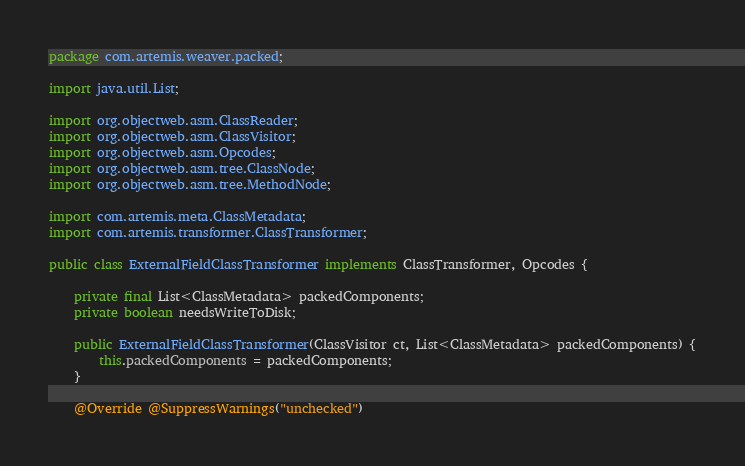Convert code to text. <code><loc_0><loc_0><loc_500><loc_500><_Java_>package com.artemis.weaver.packed;

import java.util.List;

import org.objectweb.asm.ClassReader;
import org.objectweb.asm.ClassVisitor;
import org.objectweb.asm.Opcodes;
import org.objectweb.asm.tree.ClassNode;
import org.objectweb.asm.tree.MethodNode;

import com.artemis.meta.ClassMetadata;
import com.artemis.transformer.ClassTransformer;

public class ExternalFieldClassTransformer implements ClassTransformer, Opcodes {

	private final List<ClassMetadata> packedComponents;
	private boolean needsWriteToDisk;

	public ExternalFieldClassTransformer(ClassVisitor ct, List<ClassMetadata> packedComponents) {
		this.packedComponents = packedComponents;
	}

	@Override @SuppressWarnings("unchecked")</code> 